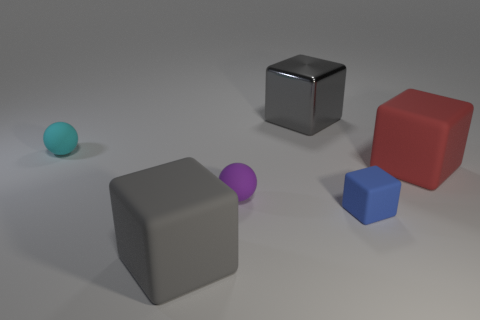Subtract all gray rubber cubes. How many cubes are left? 3 Add 3 yellow metallic cubes. How many objects exist? 9 Subtract all cyan balls. How many balls are left? 1 Subtract all balls. How many objects are left? 4 Subtract all brown cubes. Subtract all gray spheres. How many cubes are left? 4 Subtract all gray balls. How many gray blocks are left? 2 Subtract all big gray matte blocks. Subtract all large metallic things. How many objects are left? 4 Add 5 rubber spheres. How many rubber spheres are left? 7 Add 3 blue objects. How many blue objects exist? 4 Subtract 1 purple spheres. How many objects are left? 5 